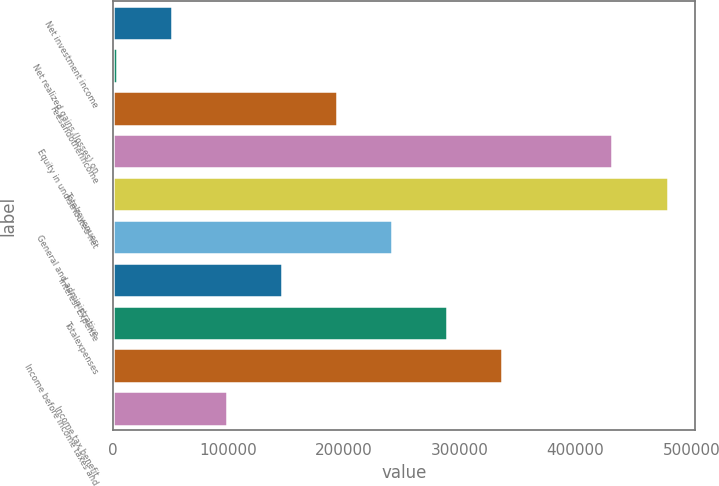Convert chart to OTSL. <chart><loc_0><loc_0><loc_500><loc_500><bar_chart><fcel>Net investment income<fcel>Net realized gains (losses) on<fcel>Feesandotherincome<fcel>Equity in undistributed net<fcel>Totalrevenues<fcel>General and administrative<fcel>Interest Expense<fcel>Totalexpenses<fcel>Income before income taxes and<fcel>Income tax benefit<nl><fcel>51014.8<fcel>3411<fcel>193826<fcel>431845<fcel>479449<fcel>241430<fcel>146222<fcel>289034<fcel>336638<fcel>98618.6<nl></chart> 